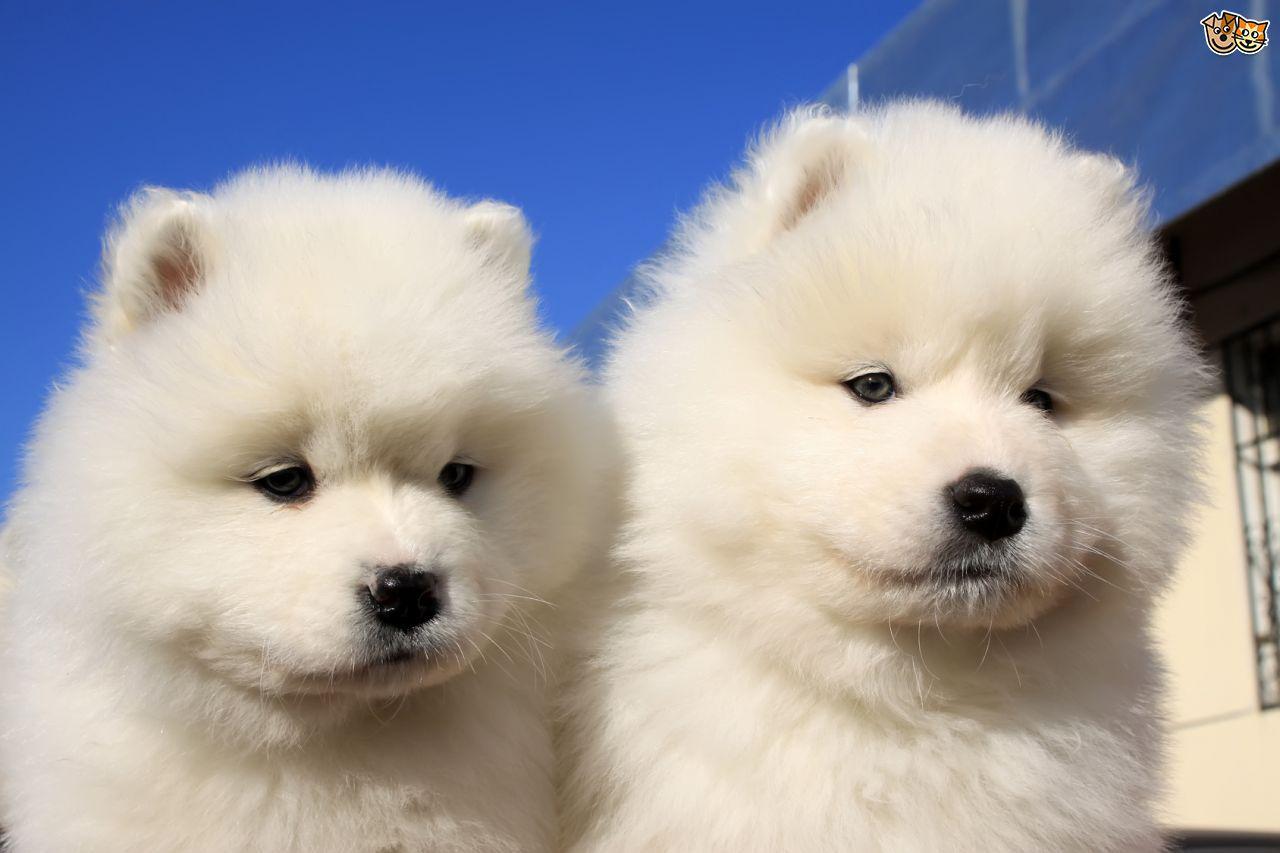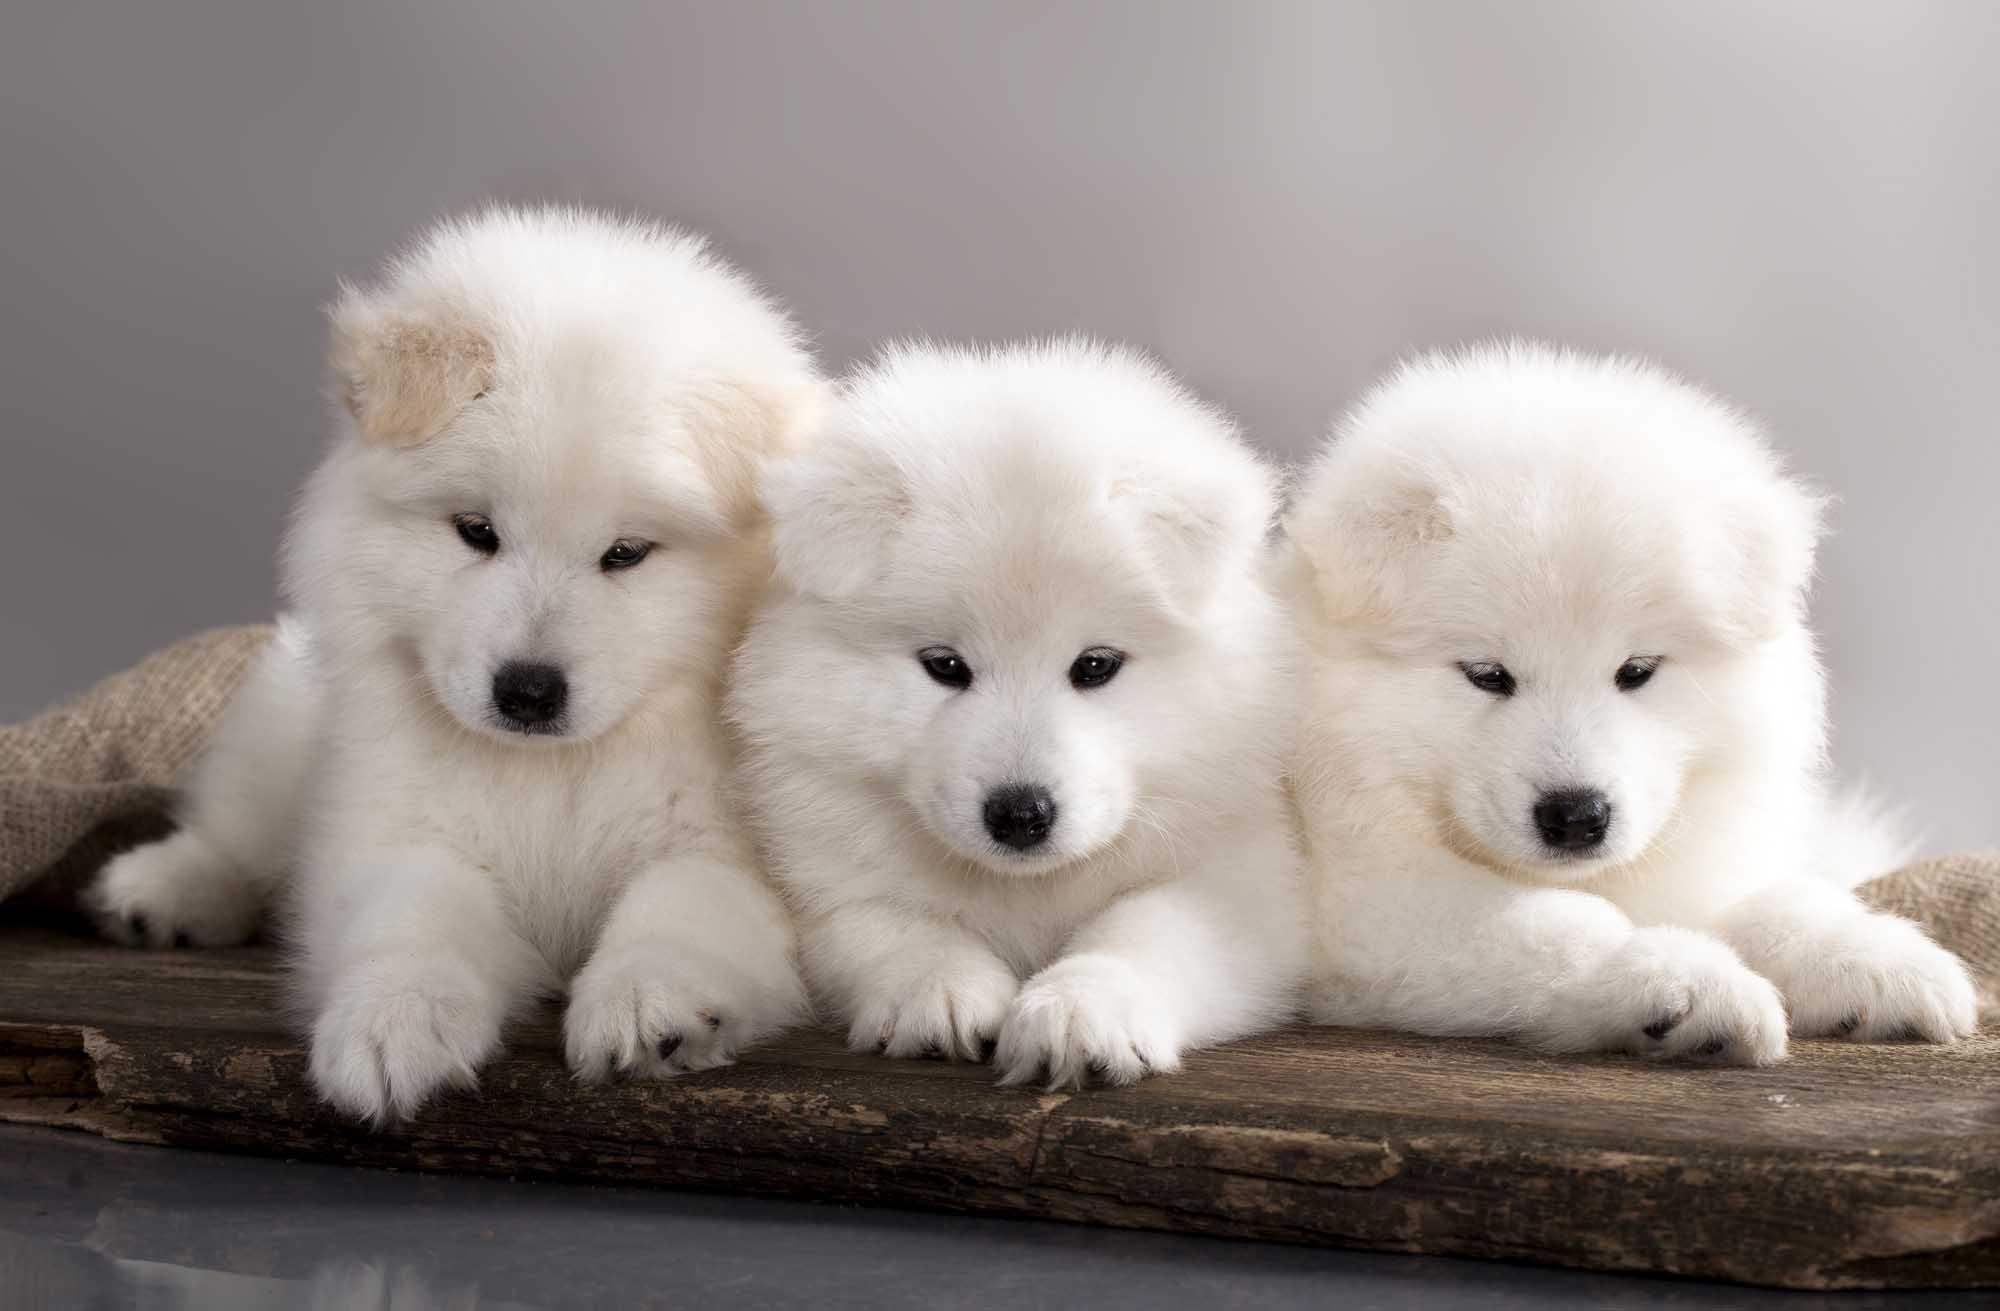The first image is the image on the left, the second image is the image on the right. For the images shown, is this caption "There are a total of 5 white dogs." true? Answer yes or no. Yes. 